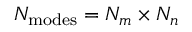<formula> <loc_0><loc_0><loc_500><loc_500>N _ { m o d e s } = N _ { m } \times N _ { n }</formula> 